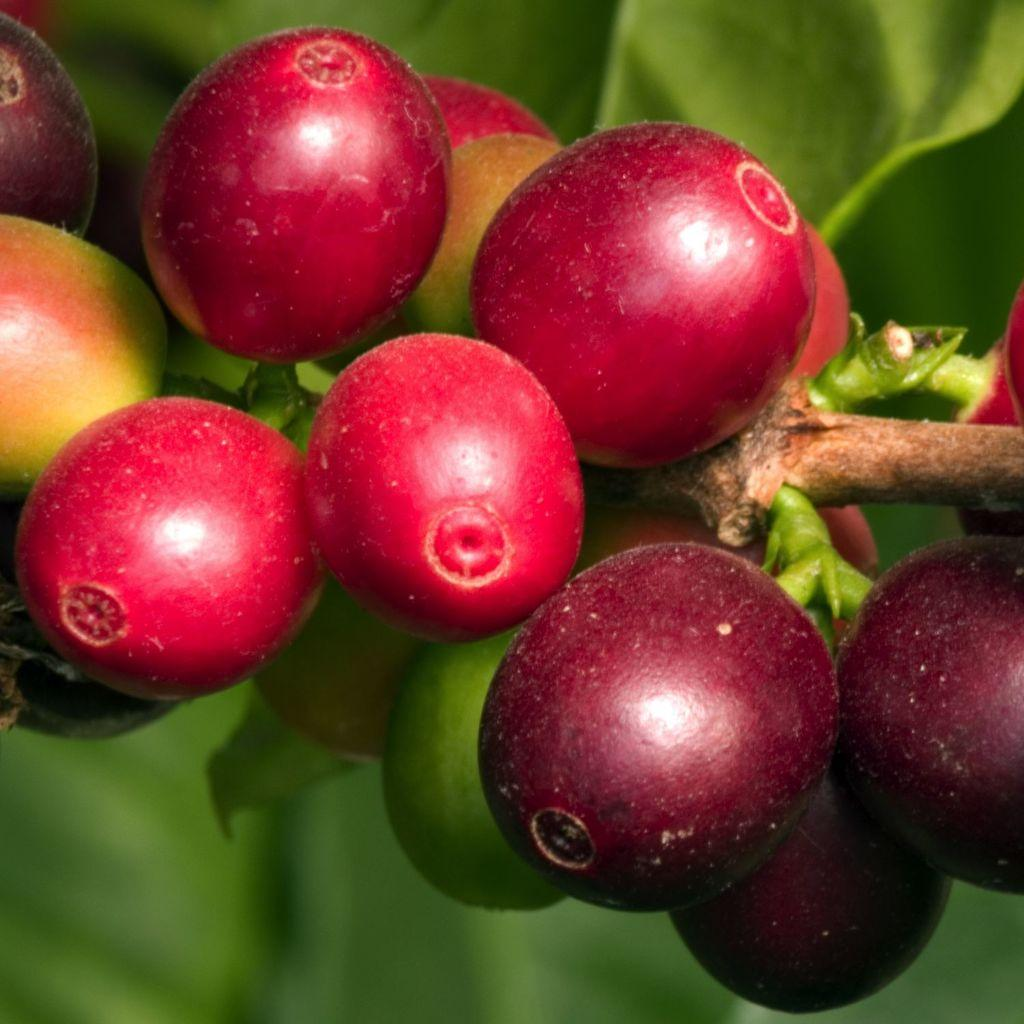What type of fruit can be seen on the plant in the image? There are berries on a plant in the image. Can you describe the background of the image? The background of the image is blurry. What type of music is playing in the background of the image? There is no music present in the image, as it only features berries on a plant and a blurry background. 